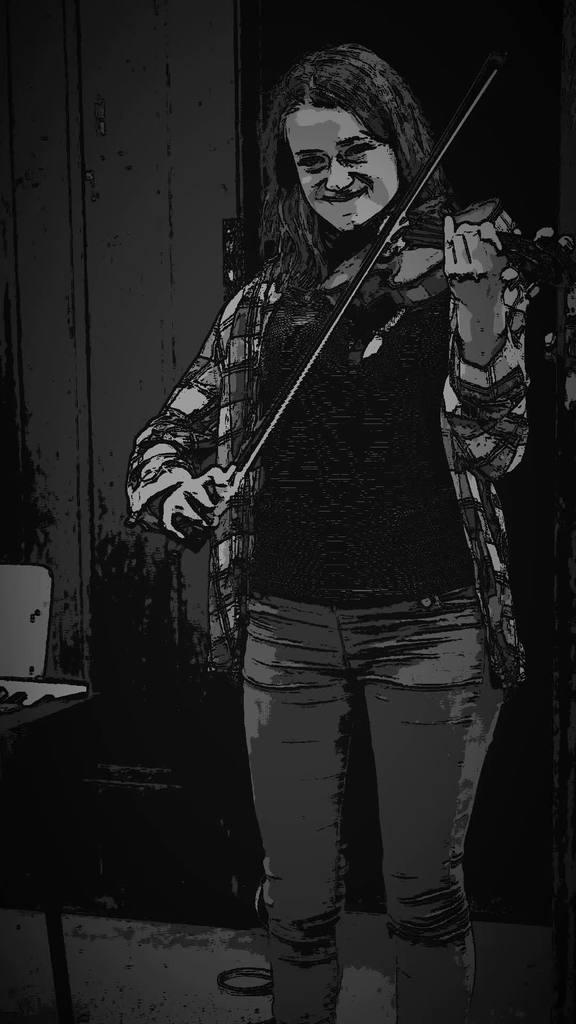Who is the main subject in the image? There is a woman in the image. What is the woman doing in the image? The woman is playing a musical instrument. What type of car is the woman driving in the image? There is no car present in the image; it features a woman playing a musical instrument. What type of horn is the woman using to play the musical instrument? The text does not mention a horn being used to play the musical instrument, as the woman is likely playing a different type of instrument, such as a guitar or violin. 